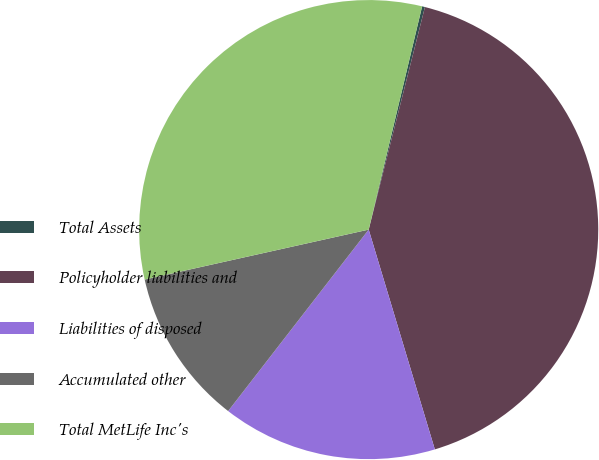Convert chart to OTSL. <chart><loc_0><loc_0><loc_500><loc_500><pie_chart><fcel>Total Assets<fcel>Policyholder liabilities and<fcel>Liabilities of disposed<fcel>Accumulated other<fcel>Total MetLife Inc's<nl><fcel>0.2%<fcel>41.41%<fcel>15.14%<fcel>11.02%<fcel>32.23%<nl></chart> 